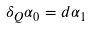<formula> <loc_0><loc_0><loc_500><loc_500>\delta _ { Q } \alpha _ { 0 } = d \alpha _ { 1 }</formula> 